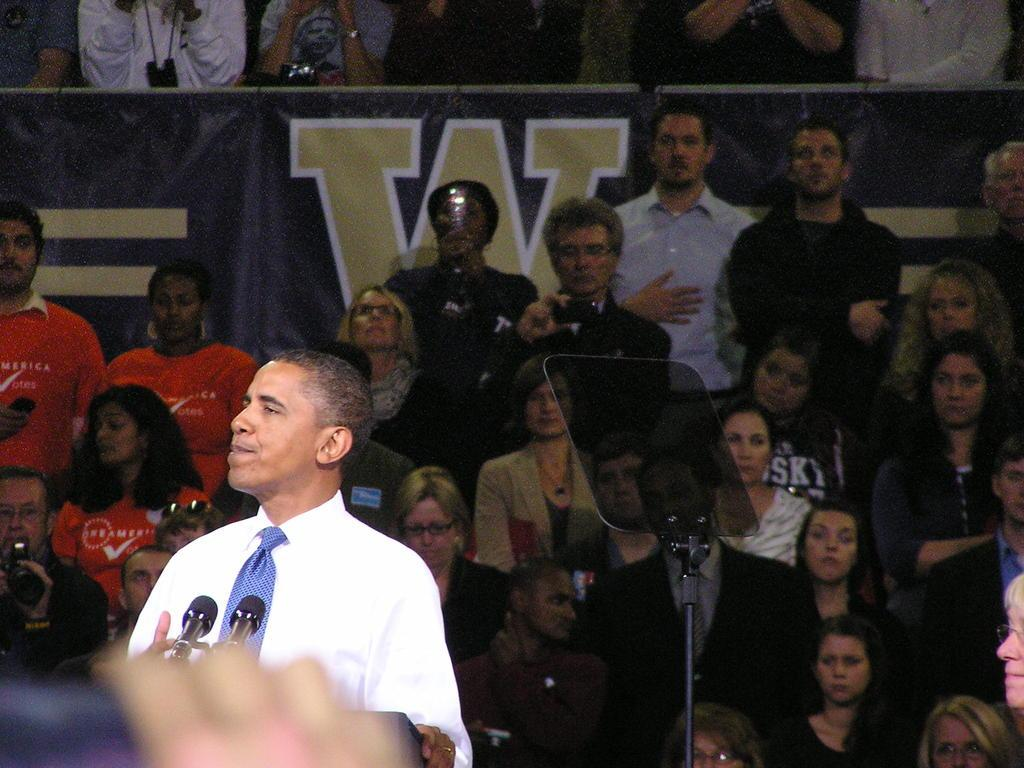What is the person near in the image? The person is standing near a speaker's stand. What is the person holding in the image? The person is holding microphones. What can be seen in the background of the image? There is a stand, people sitting on chairs, and a board visible in the background. What type of garden can be seen in the background of the image? There is no garden visible in the background of the image. What material is the plastic used for in the image? There is no plastic mentioned or visible in the image. 